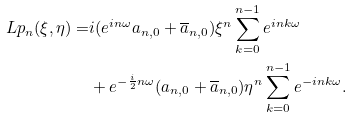<formula> <loc_0><loc_0><loc_500><loc_500>L p _ { n } ( \xi , \eta ) = & i ( e ^ { i n \omega } a _ { n , 0 } + \overline { a } _ { n , 0 } ) \xi ^ { n } \sum _ { k = 0 } ^ { n - 1 } e ^ { i n k \omega } \\ & + e ^ { - \frac { i } { 2 } n \omega } ( a _ { n , 0 } + \overline { a } _ { n , 0 } ) \eta ^ { n } \sum _ { k = 0 } ^ { n - 1 } e ^ { - i n k \omega } .</formula> 